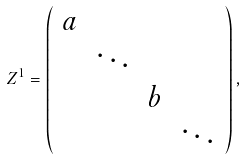<formula> <loc_0><loc_0><loc_500><loc_500>Z ^ { 1 } = \left ( \begin{array} { c c c c } a & & \\ & \ddots & \\ & & b & \\ & & & \ddots \end{array} \right ) ,</formula> 